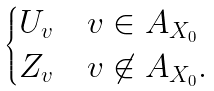<formula> <loc_0><loc_0><loc_500><loc_500>\begin{cases} U _ { v } & v \in A _ { X _ { 0 } } \\ Z _ { v } & v \not \in A _ { X _ { 0 } } . \end{cases}</formula> 